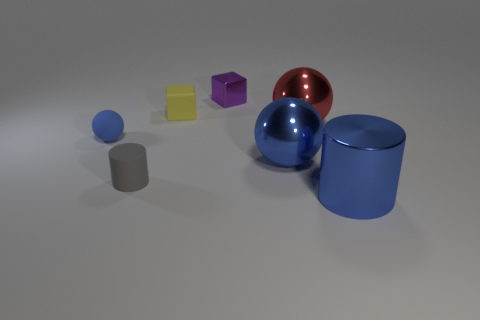Subtract all red shiny spheres. How many spheres are left? 2 Add 2 small red matte cylinders. How many objects exist? 9 Subtract all purple blocks. How many blocks are left? 1 Subtract all cubes. How many objects are left? 5 Subtract 2 balls. How many balls are left? 1 Subtract all brown cylinders. How many purple cubes are left? 1 Subtract all tiny cyan matte cubes. Subtract all cylinders. How many objects are left? 5 Add 7 blue cylinders. How many blue cylinders are left? 8 Add 1 tiny yellow metallic spheres. How many tiny yellow metallic spheres exist? 1 Subtract 1 gray cylinders. How many objects are left? 6 